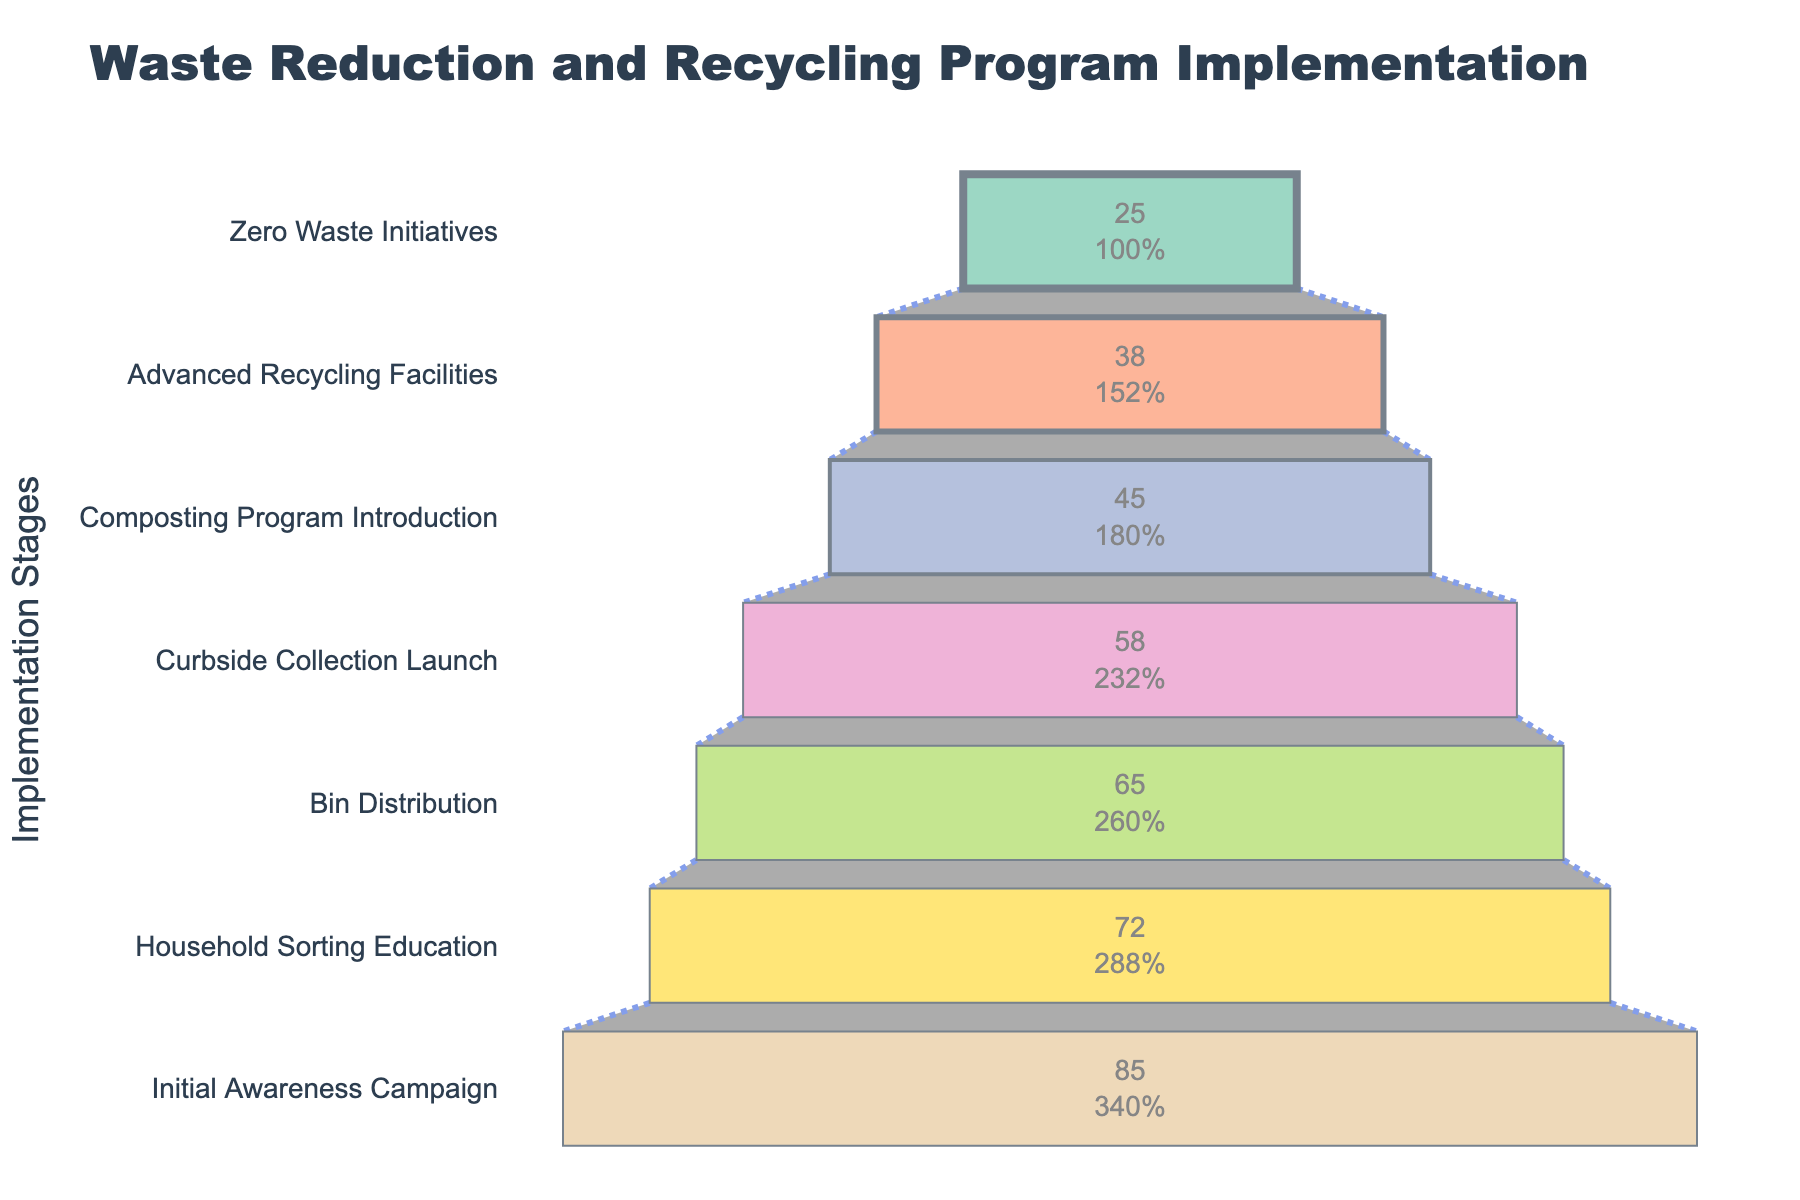What is the participation rate for the Household Sorting Education stage? The Household Sorting Education stage is labeled with a participation rate inside the funnel shape.
Answer: 72% Which stage has the highest participation rate? The funnel chart is ordered from top (highest participation rate) to bottom (lowest participation rate). The first stage listed is the Initial Awareness Campaign, thus having the highest participation rate.
Answer: Initial Awareness Campaign How does the participation rate change from Bin Distribution to Composting Program Introduction? The participation rate for Bin Distribution is 65%, and for Composting Program Introduction, it is 45%. The change can be calculated by subtracting 45% from 65%.
Answer: 20% What is the average participation rate for the stages displayed in the chart? To find the average, sum all the participation rates (85 + 72 + 65 + 58 + 45 + 38 + 25) and divide by the number of stages (7). The total sum is 388, so the average is 388 / 7.
Answer: 55.43% Which two stages have participation rates below 40%? By looking at the funnel chart, the stages with participation rates below 40% are Advanced Recycling Facilities (38%) and Zero Waste Initiatives (25%).
Answer: Advanced Recycling Facilities, Zero Waste Initiatives What is the total decrease in participation rate from Initial Awareness Campaign to Zero Waste Initiatives? The initial participation rate is 85% (Initial Awareness Campaign), and the final participation rate is 25% (Zero Waste Initiatives). The total decrease is 85% - 25%.
Answer: 60% How many total participants are involved if the total population is 10,000 at the Initial Awareness Campaign stage? With an 85% participation rate at the Initial Awareness Campaign stage, you would have 85% of 10,000, which can be calculated as: 0.85 x 10,000.
Answer: 8,500 participants What percentage of participants are lost from Curbside Collection Launch to Zero Waste Initiatives in terms of the initial population? The initial population (Curbside Collection Launch) participation rate is 58%, and the final population (Zero Waste Initiatives) participation rate is 25%. The percentage lost is calculated by (58% - 25%) / 58% * 100.
Answer: 56.9% 